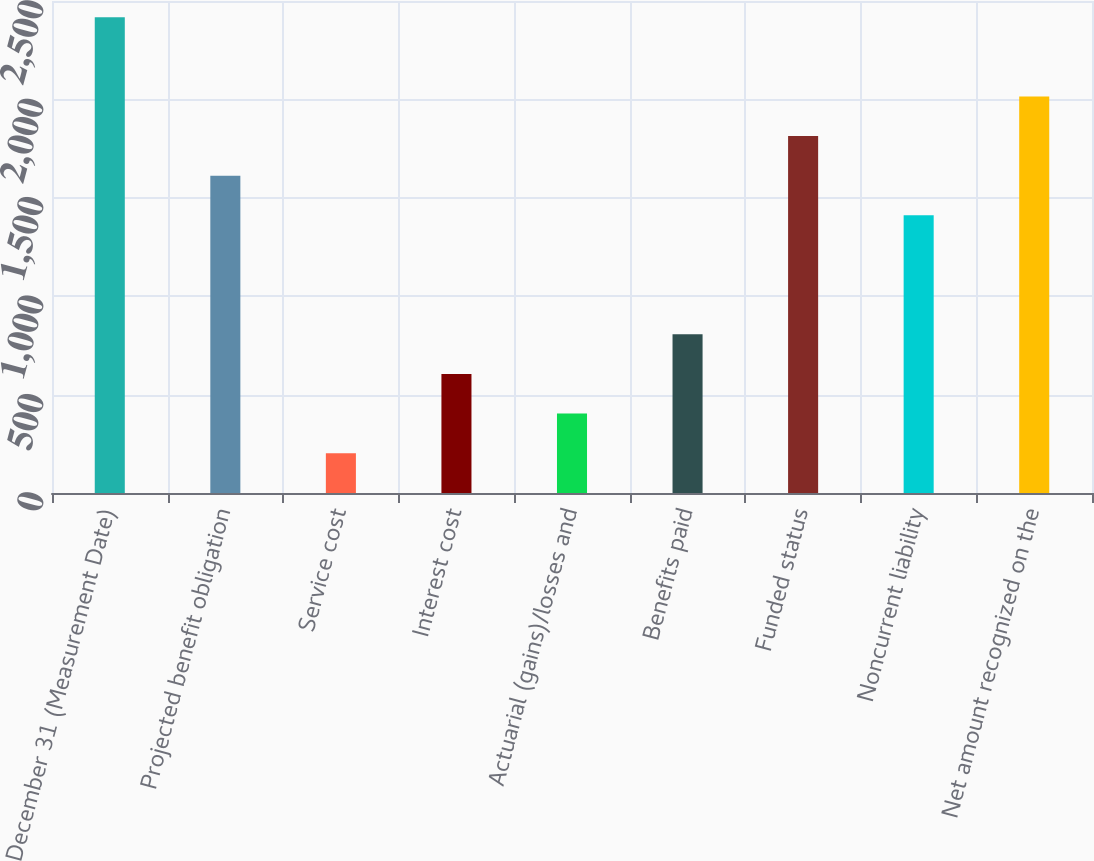Convert chart to OTSL. <chart><loc_0><loc_0><loc_500><loc_500><bar_chart><fcel>December 31 (Measurement Date)<fcel>Projected benefit obligation<fcel>Service cost<fcel>Interest cost<fcel>Actuarial (gains)/losses and<fcel>Benefits paid<fcel>Funded status<fcel>Noncurrent liability<fcel>Net amount recognized on the<nl><fcel>2417.8<fcel>1612.2<fcel>202.4<fcel>605.2<fcel>403.8<fcel>806.6<fcel>1813.6<fcel>1410.8<fcel>2015<nl></chart> 